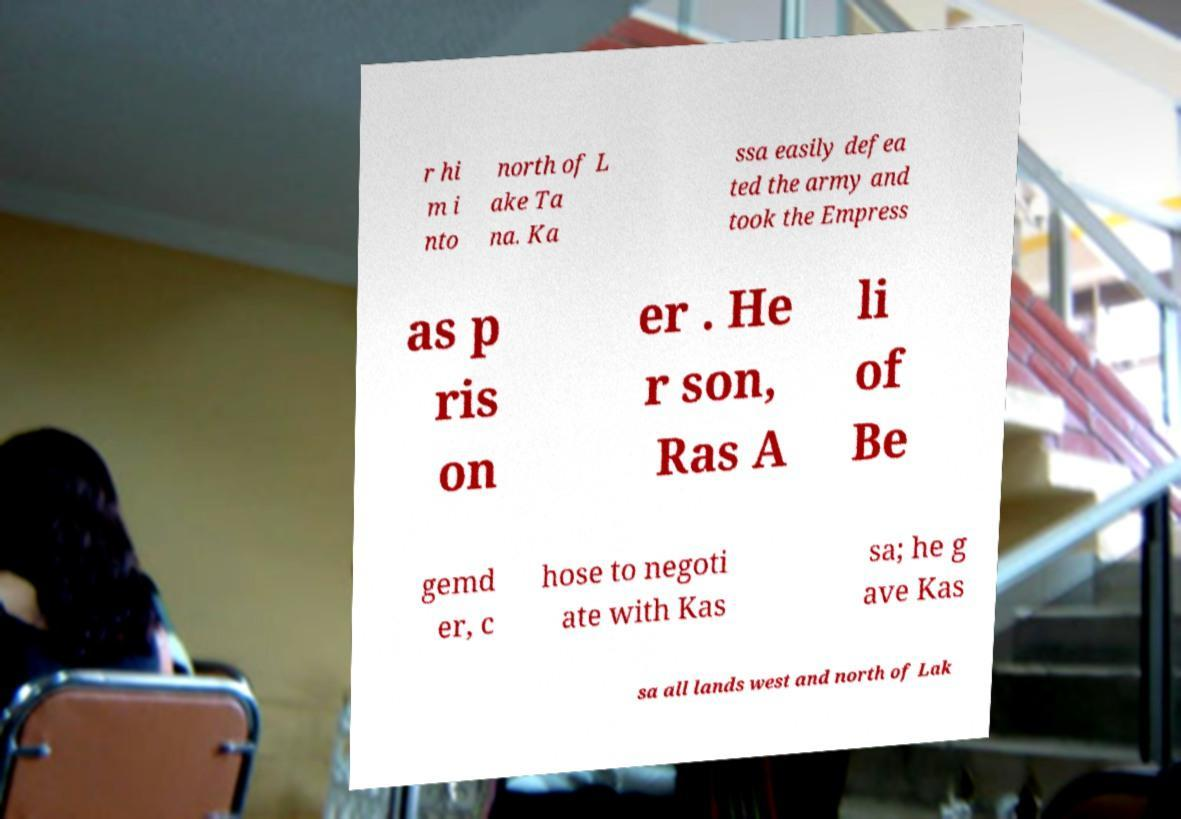For documentation purposes, I need the text within this image transcribed. Could you provide that? r hi m i nto north of L ake Ta na. Ka ssa easily defea ted the army and took the Empress as p ris on er . He r son, Ras A li of Be gemd er, c hose to negoti ate with Kas sa; he g ave Kas sa all lands west and north of Lak 